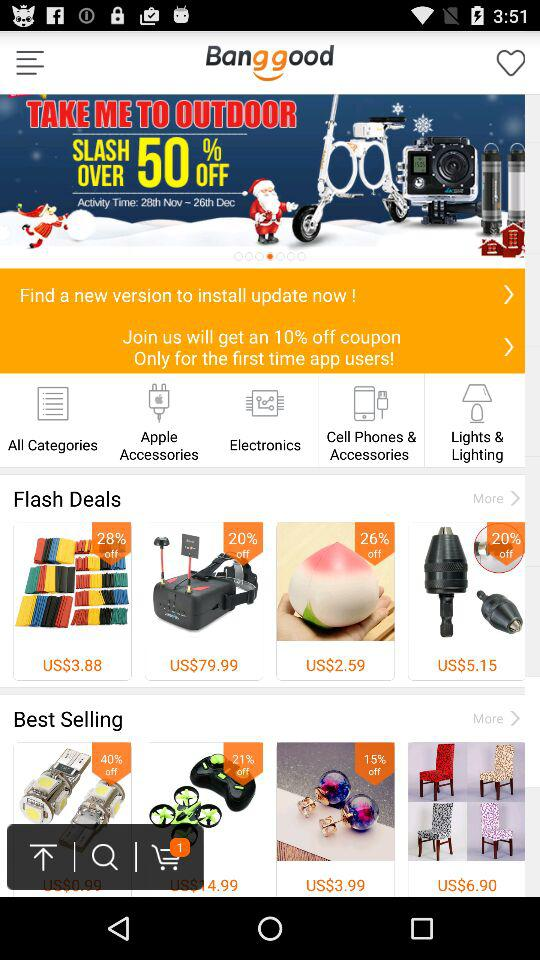What is the name of the application? The name of the application is "Banggood". 